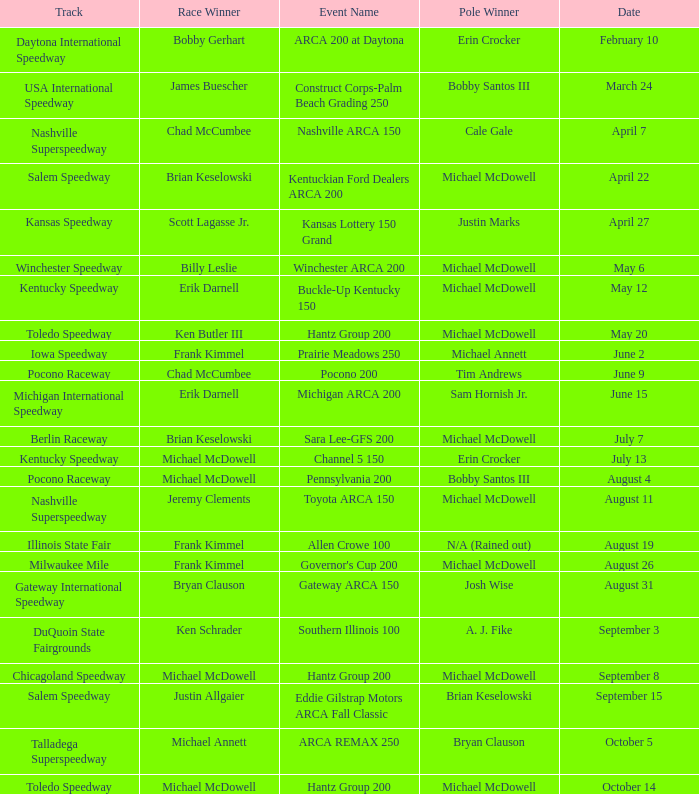Tell me the event name for michael mcdowell and billy leslie Winchester ARCA 200. 